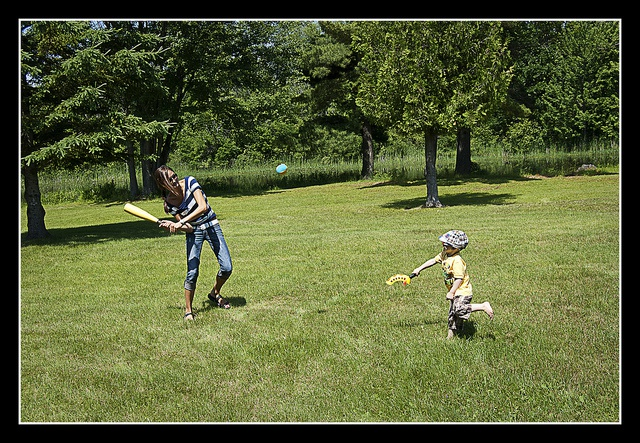Describe the objects in this image and their specific colors. I can see people in black, olive, and ivory tones, people in black, white, gray, and olive tones, baseball bat in black, beige, khaki, and olive tones, and sports ball in black, lightblue, olive, and white tones in this image. 